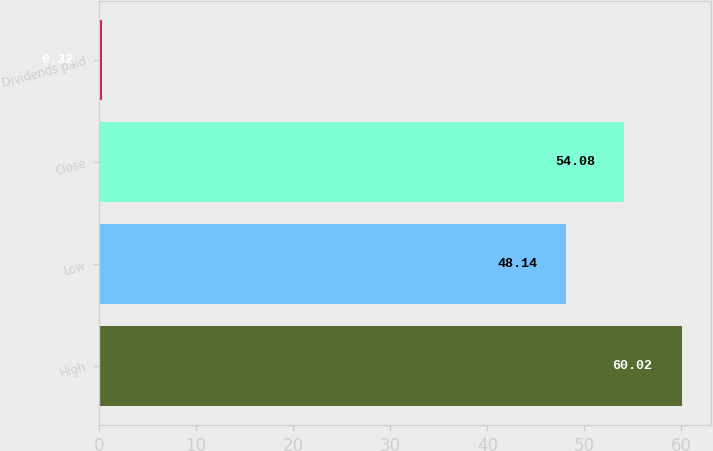Convert chart. <chart><loc_0><loc_0><loc_500><loc_500><bar_chart><fcel>High<fcel>Low<fcel>Close<fcel>Dividends paid<nl><fcel>60.02<fcel>48.14<fcel>54.08<fcel>0.32<nl></chart> 